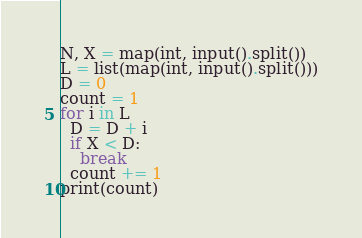Convert code to text. <code><loc_0><loc_0><loc_500><loc_500><_Python_>N, X = map(int, input().split())
L = list(map(int, input().split()))
D = 0
count = 1
for i in L
  D = D + i
  if X < D:
    break
  count += 1
print(count)</code> 